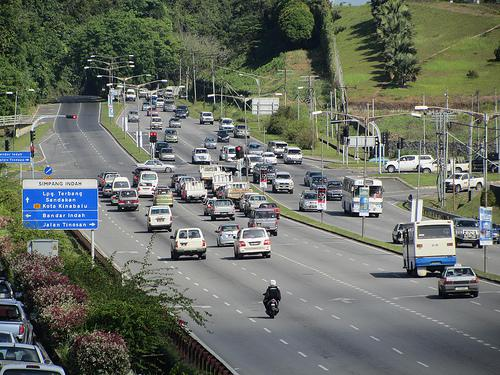Question: who is driving the motorcycle?
Choices:
A. A man.
B. A woman.
C. A kid.
D. A person.
Answer with the letter. Answer: D Question: what is the color of the grass?
Choices:
A. Brown.
B. Yellow.
C. White.
D. Green.
Answer with the letter. Answer: D Question: what is the color of the sign?
Choices:
A. Red.
B. Yellow.
C. White.
D. Blue.
Answer with the letter. Answer: D Question: what is the color of the road?
Choices:
A. Black.
B. Red.
C. Gray.
D. White.
Answer with the letter. Answer: C 